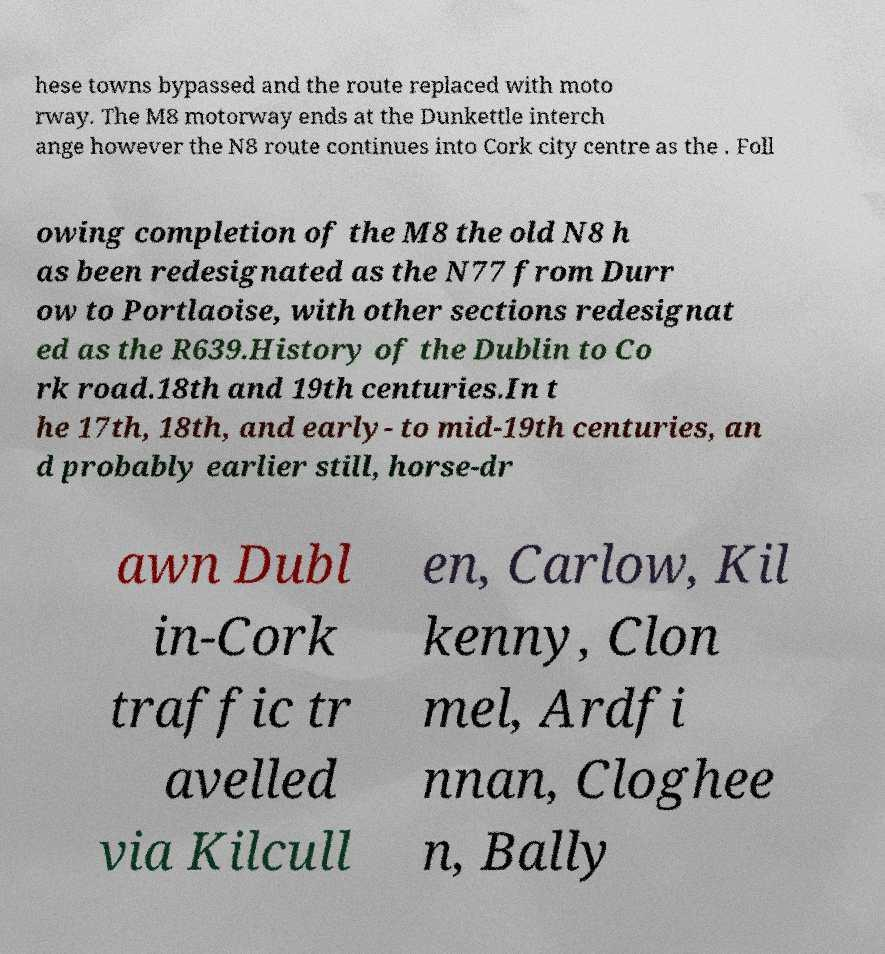Can you read and provide the text displayed in the image?This photo seems to have some interesting text. Can you extract and type it out for me? hese towns bypassed and the route replaced with moto rway. The M8 motorway ends at the Dunkettle interch ange however the N8 route continues into Cork city centre as the . Foll owing completion of the M8 the old N8 h as been redesignated as the N77 from Durr ow to Portlaoise, with other sections redesignat ed as the R639.History of the Dublin to Co rk road.18th and 19th centuries.In t he 17th, 18th, and early- to mid-19th centuries, an d probably earlier still, horse-dr awn Dubl in-Cork traffic tr avelled via Kilcull en, Carlow, Kil kenny, Clon mel, Ardfi nnan, Cloghee n, Bally 